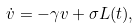<formula> <loc_0><loc_0><loc_500><loc_500>\dot { v } = - \gamma v + \sigma L ( t ) ,</formula> 